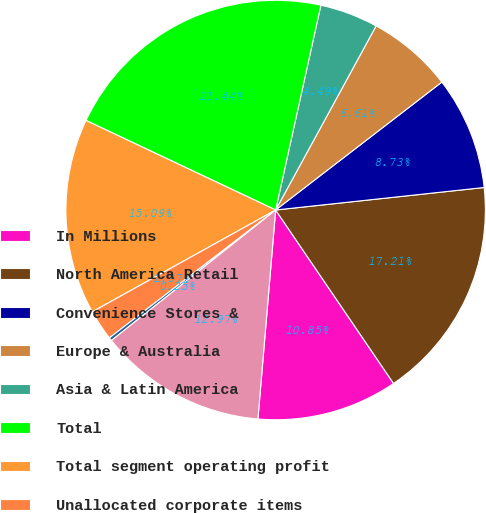Convert chart. <chart><loc_0><loc_0><loc_500><loc_500><pie_chart><fcel>In Millions<fcel>North America Retail<fcel>Convenience Stores &<fcel>Europe & Australia<fcel>Asia & Latin America<fcel>Total<fcel>Total segment operating profit<fcel>Unallocated corporate items<fcel>Restructuring impairment and<fcel>Operating profit<nl><fcel>10.85%<fcel>17.21%<fcel>8.73%<fcel>6.61%<fcel>4.49%<fcel>21.44%<fcel>15.09%<fcel>2.37%<fcel>0.25%<fcel>12.97%<nl></chart> 